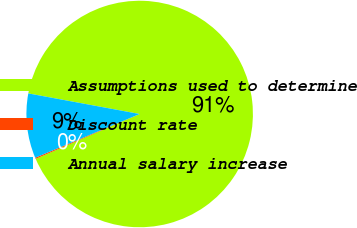Convert chart. <chart><loc_0><loc_0><loc_500><loc_500><pie_chart><fcel>Assumptions used to determine<fcel>Discount rate<fcel>Annual salary increase<nl><fcel>90.61%<fcel>0.17%<fcel>9.22%<nl></chart> 